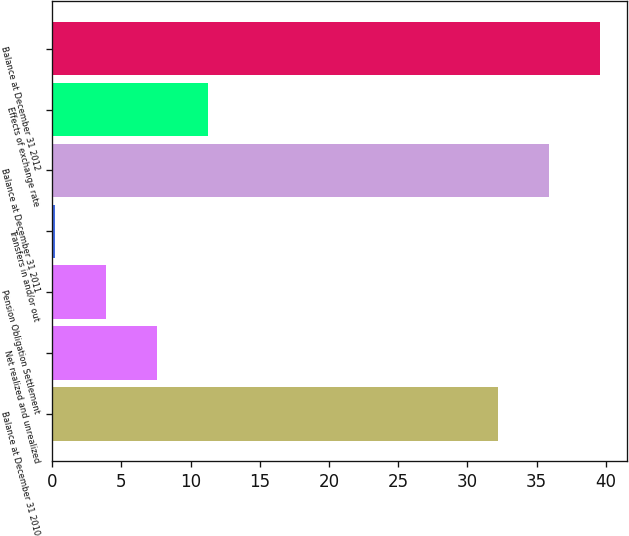<chart> <loc_0><loc_0><loc_500><loc_500><bar_chart><fcel>Balance at December 31 2010<fcel>Net realized and unrealized<fcel>Pension Obligation Settlement<fcel>Transfers in and/or out<fcel>Balance at December 31 2011<fcel>Effects of exchange rate<fcel>Balance at December 31 2012<nl><fcel>32.2<fcel>7.58<fcel>3.89<fcel>0.2<fcel>35.89<fcel>11.27<fcel>39.58<nl></chart> 